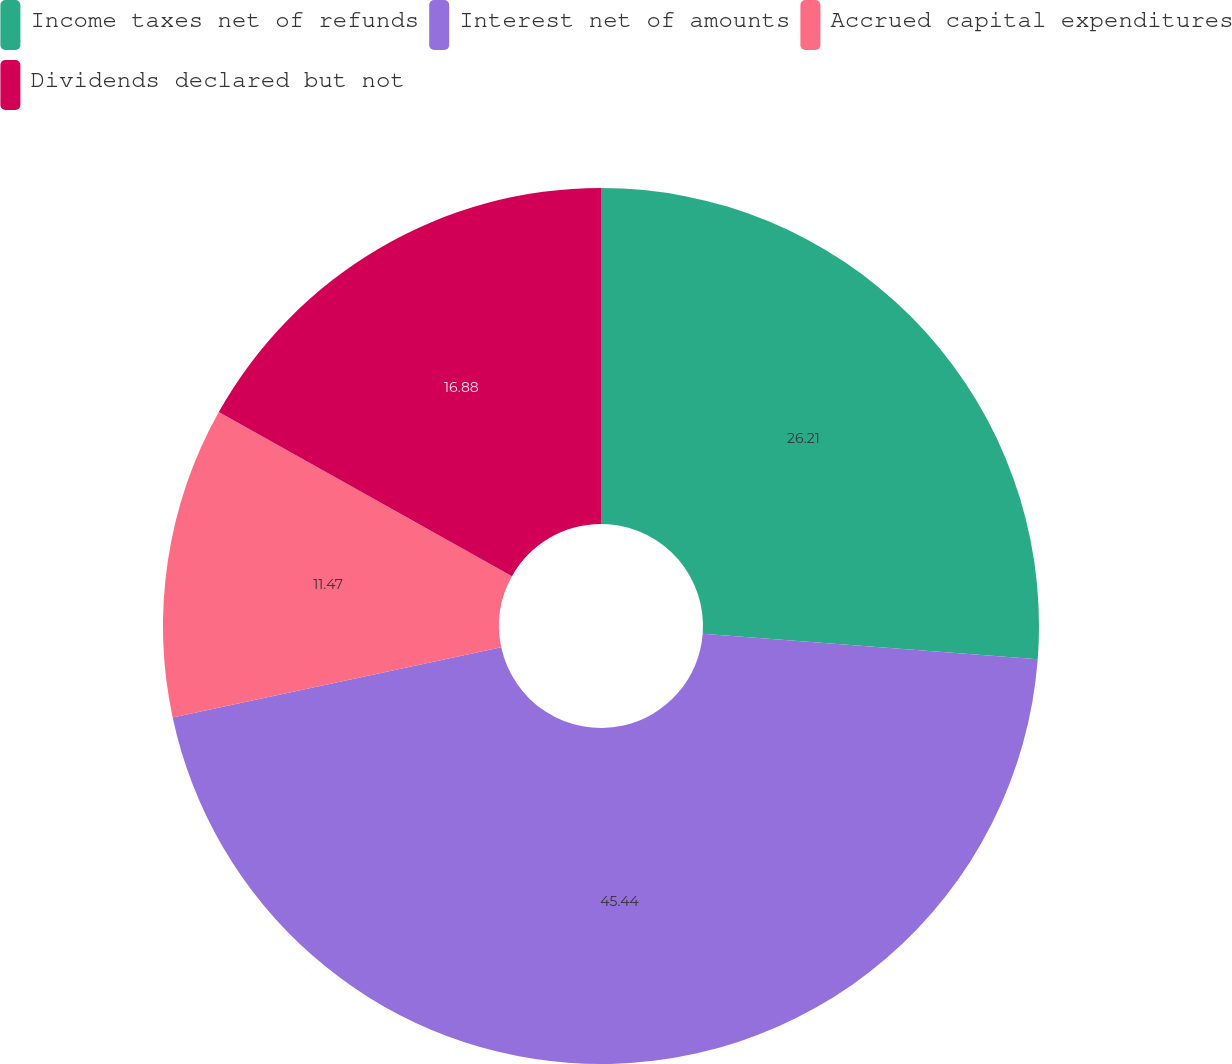Convert chart to OTSL. <chart><loc_0><loc_0><loc_500><loc_500><pie_chart><fcel>Income taxes net of refunds<fcel>Interest net of amounts<fcel>Accrued capital expenditures<fcel>Dividends declared but not<nl><fcel>26.21%<fcel>45.44%<fcel>11.47%<fcel>16.88%<nl></chart> 